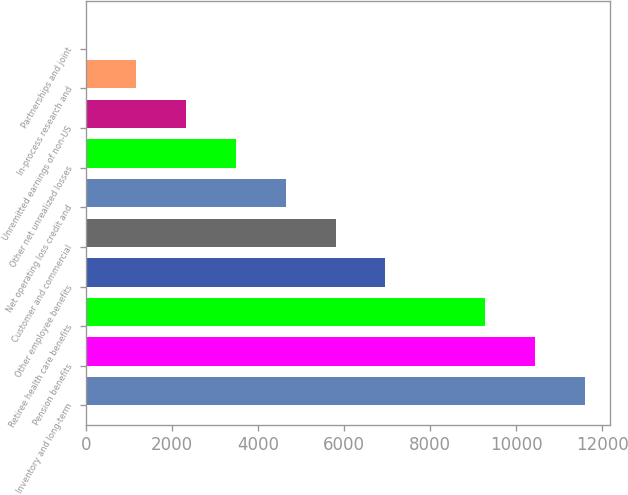<chart> <loc_0><loc_0><loc_500><loc_500><bar_chart><fcel>Inventory and long-term<fcel>Pension benefits<fcel>Retiree health care benefits<fcel>Other employee benefits<fcel>Customer and commercial<fcel>Net operating loss credit and<fcel>Other net unrealized losses<fcel>Unremitted earnings of non-US<fcel>In-process research and<fcel>Partnerships and joint<nl><fcel>11589<fcel>10431<fcel>9273<fcel>6957<fcel>5799<fcel>4641<fcel>3483<fcel>2325<fcel>1167<fcel>9<nl></chart> 